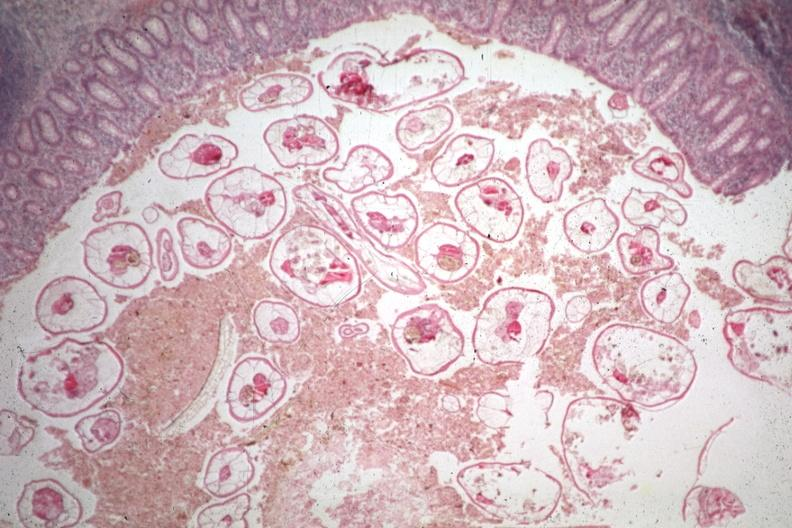what does this image show?
Answer the question using a single word or phrase. Typical excellent pinworm 